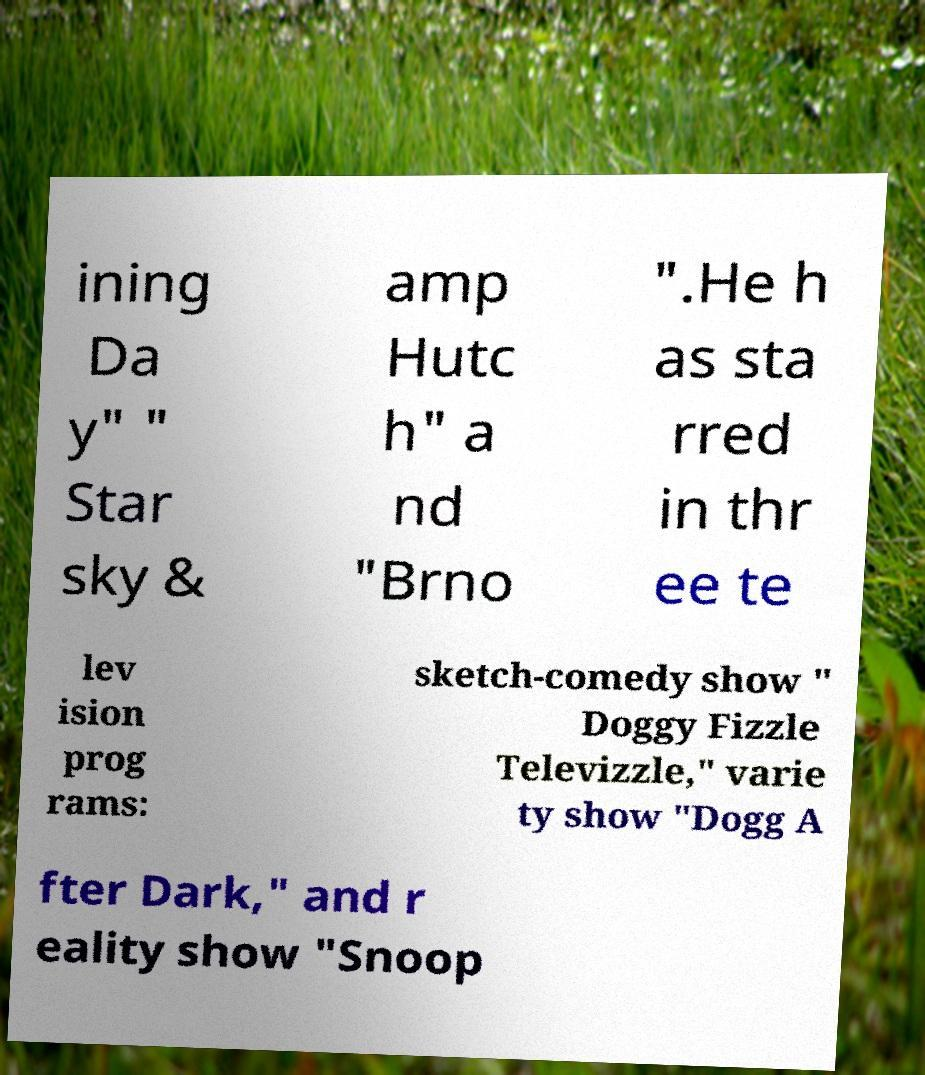Can you read and provide the text displayed in the image?This photo seems to have some interesting text. Can you extract and type it out for me? ining Da y" " Star sky & amp Hutc h" a nd "Brno ".He h as sta rred in thr ee te lev ision prog rams: sketch-comedy show " Doggy Fizzle Televizzle," varie ty show "Dogg A fter Dark," and r eality show "Snoop 